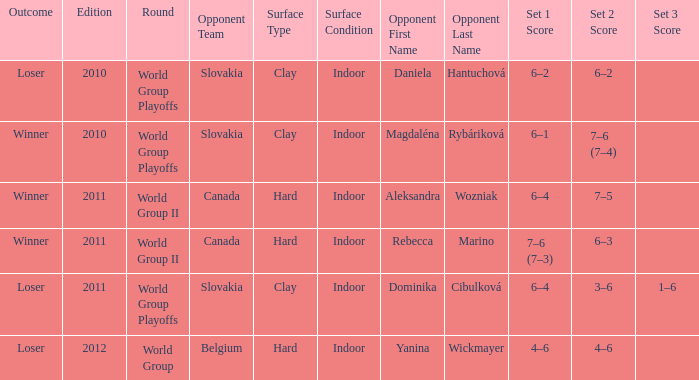What was the score when the opposing team was from Belgium? 4–6, 4–6. 